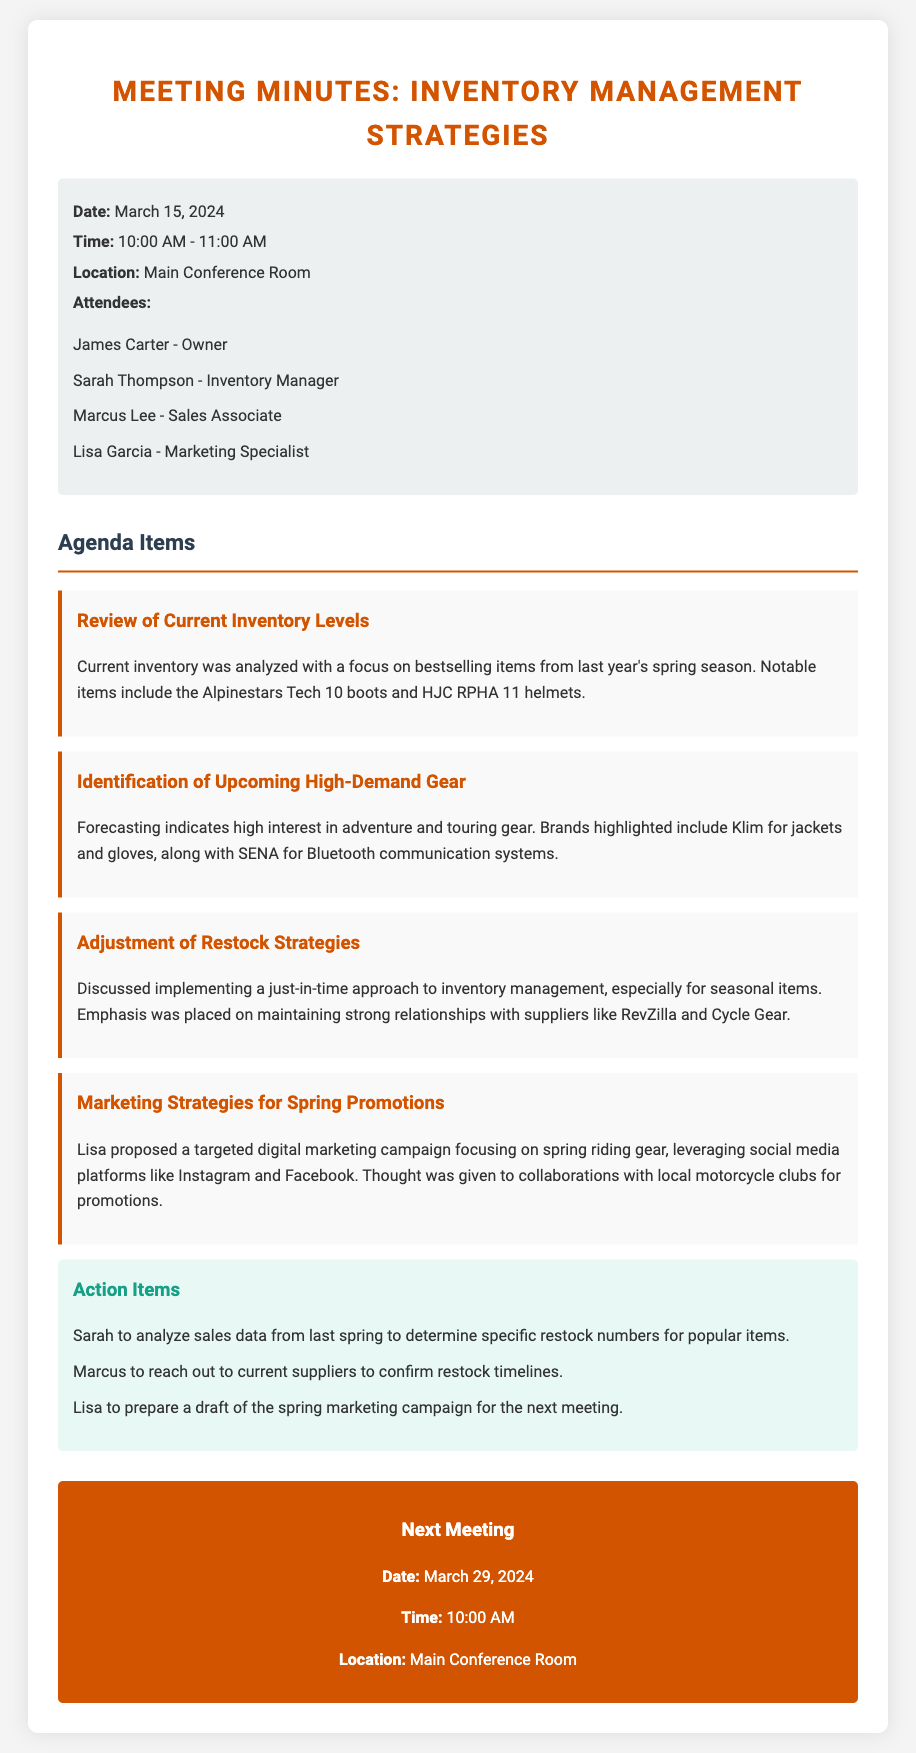What was the date of the meeting? The date of the meeting is specified in the meeting details section.
Answer: March 15, 2024 Who is the inventory manager? The document lists the attendees and their roles, indicating who the inventory manager is.
Answer: Sarah Thompson What gear brands were mentioned for high-demand items? The discussion on upcoming high-demand gear highlights specific brands for focus.
Answer: Klim and SENA What inventory management strategy was discussed? The meeting outlined a specific approach to managing inventory during the discussion on restocking.
Answer: Just-in-time When is the next meeting scheduled? The date and time for the next meeting are indicated in the next meeting section.
Answer: March 29, 2024 Which item is noted as a bestselling boot from last spring? The minutes specify particular bestselling items from the previous season during an inventory review.
Answer: Alpinestars Tech 10 boots What is the focus of the digital marketing campaign proposed by Lisa? The marketing strategy section notes the theme of the proposed campaign.
Answer: Spring riding gear How many attendees were at the meeting? The list of attendees provides the number of individuals present at the meeting.
Answer: Four 